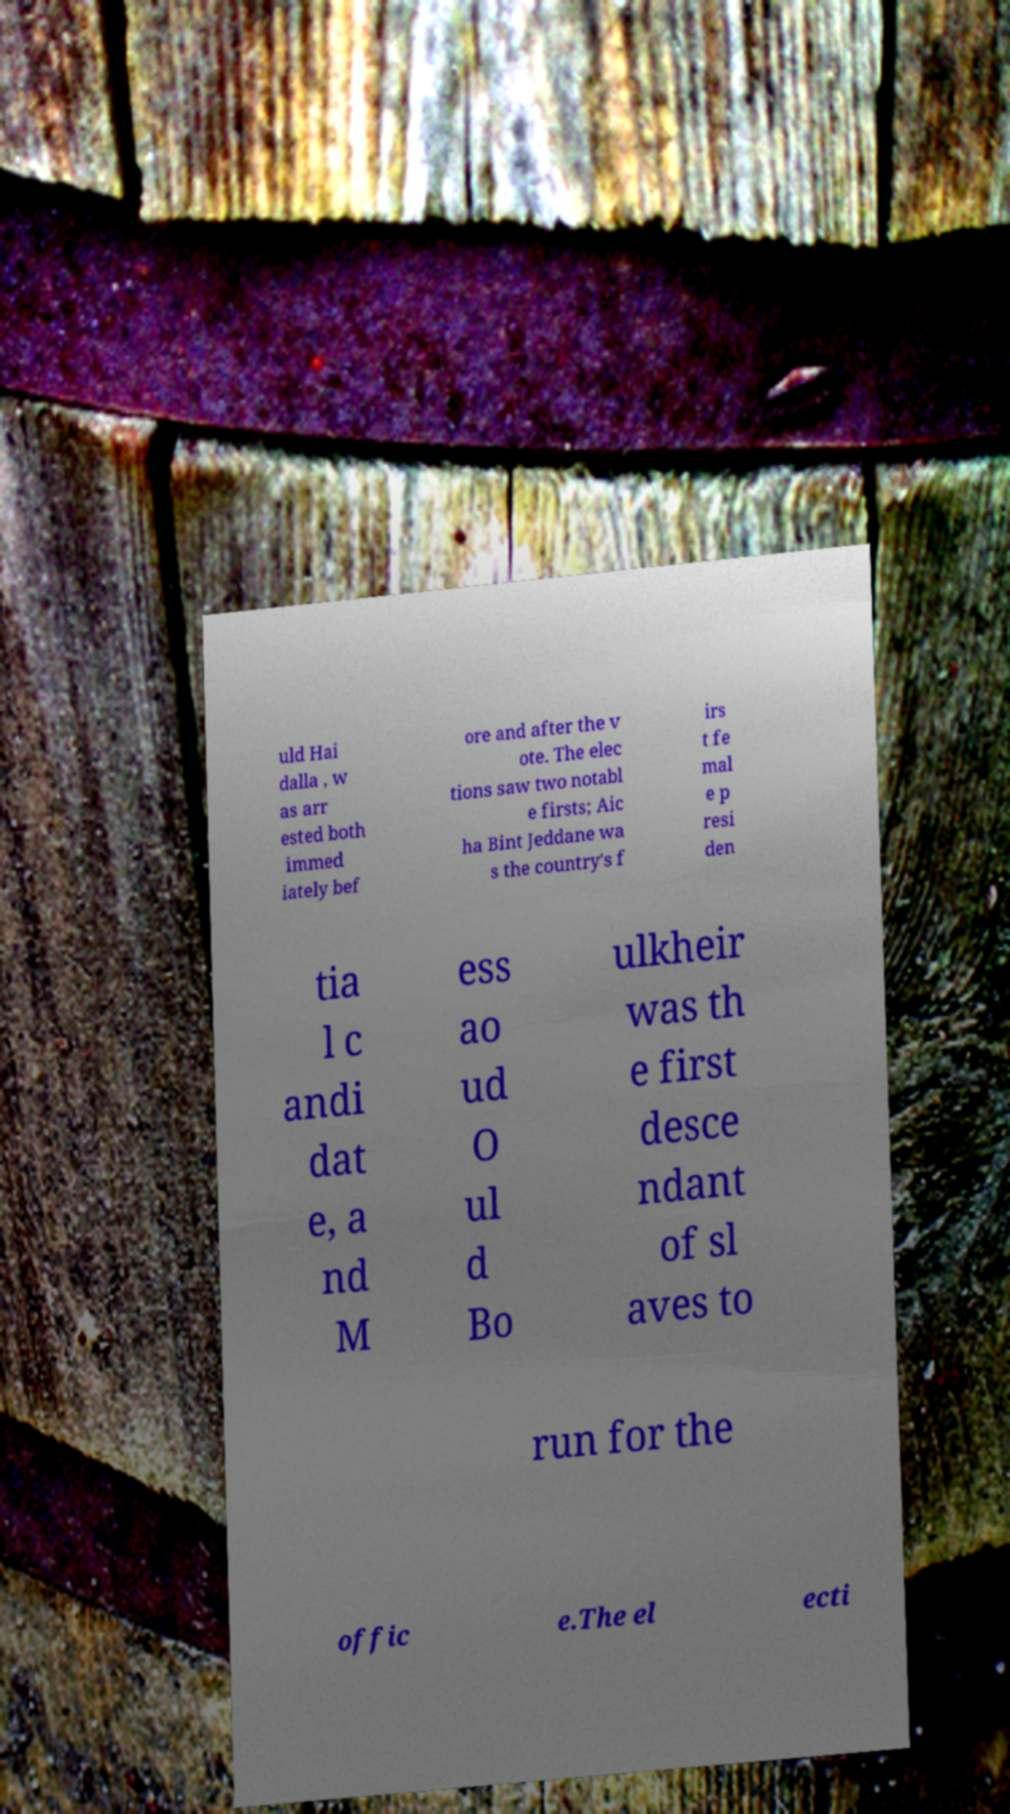What messages or text are displayed in this image? I need them in a readable, typed format. uld Hai dalla , w as arr ested both immed iately bef ore and after the v ote. The elec tions saw two notabl e firsts; Aic ha Bint Jeddane wa s the country's f irs t fe mal e p resi den tia l c andi dat e, a nd M ess ao ud O ul d Bo ulkheir was th e first desce ndant of sl aves to run for the offic e.The el ecti 